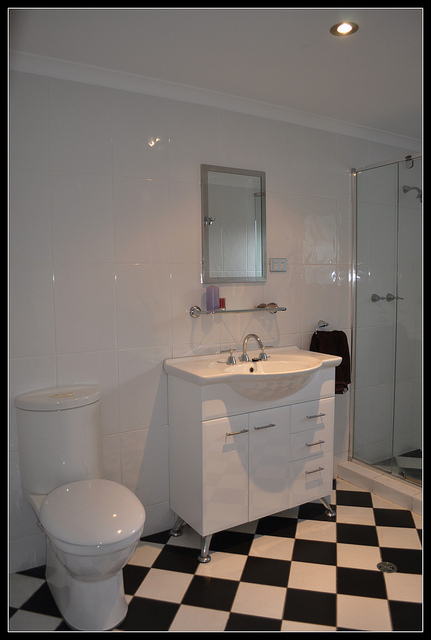<image>What pattern is on the toilet seat cover? The toilet seat cover appears to be solid white with no pattern. What country is this likely to be located in? It is ambiguous what country this is likely to be located in. It could be USA or France. What is the date when the photo was taken? It is unknown what the exact date is when the photo was taken. What country is this likely to be located in? I don't know what country this is likely to be located in. It can be either USA or America. What pattern is on the toilet seat cover? I don't know what pattern is on the toilet seat cover. It can be either solid white or solid color. What is the date when the photo was taken? I don't know the exact date when the photo was taken. It can be any of the dates mentioned: '2016', '06 15 2016', '1 25 2016', '2016', '2011', 'january 1', '1 1 2017', 'no date', '2010'.
 